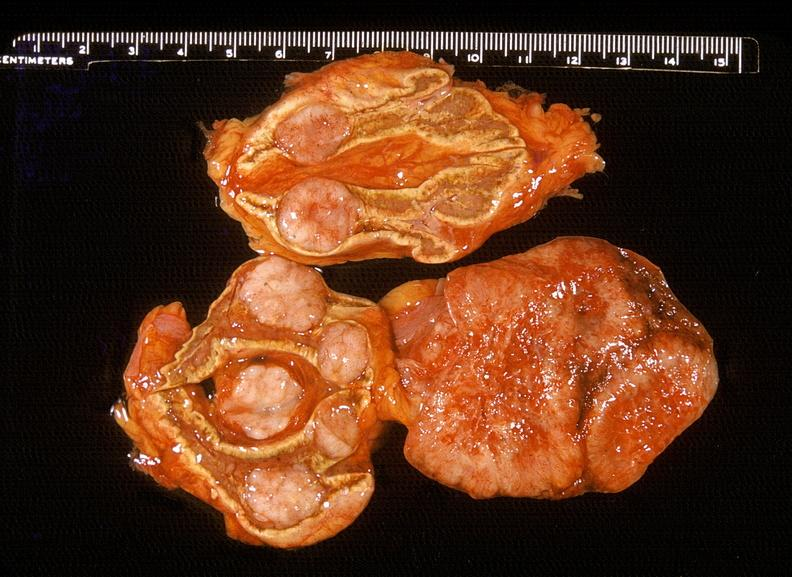what does this image show?
Answer the question using a single word or phrase. Adrenal 